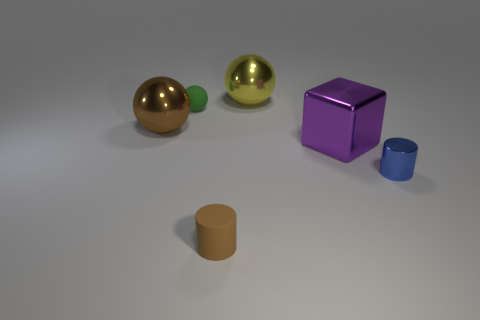There is a tiny matte object that is in front of the purple shiny object; is its shape the same as the big purple object?
Provide a succinct answer. No. What is the small thing right of the brown rubber cylinder made of?
Provide a succinct answer. Metal. What shape is the big thing that is on the left side of the metal ball that is right of the matte cylinder?
Make the answer very short. Sphere. Do the large purple object and the brown thing that is in front of the big purple shiny cube have the same shape?
Give a very brief answer. No. What number of large blocks are behind the metallic thing behind the big brown thing?
Keep it short and to the point. 0. There is a brown object that is the same shape as the tiny green rubber object; what is it made of?
Your answer should be very brief. Metal. What number of blue objects are either large shiny spheres or large shiny things?
Offer a terse response. 0. Are there any other things that are the same color as the shiny block?
Keep it short and to the point. No. There is a sphere that is in front of the small object behind the blue metal thing; what color is it?
Offer a very short reply. Brown. Is the number of blocks that are behind the purple shiny thing less than the number of big blocks to the left of the tiny green rubber thing?
Provide a short and direct response. No. 